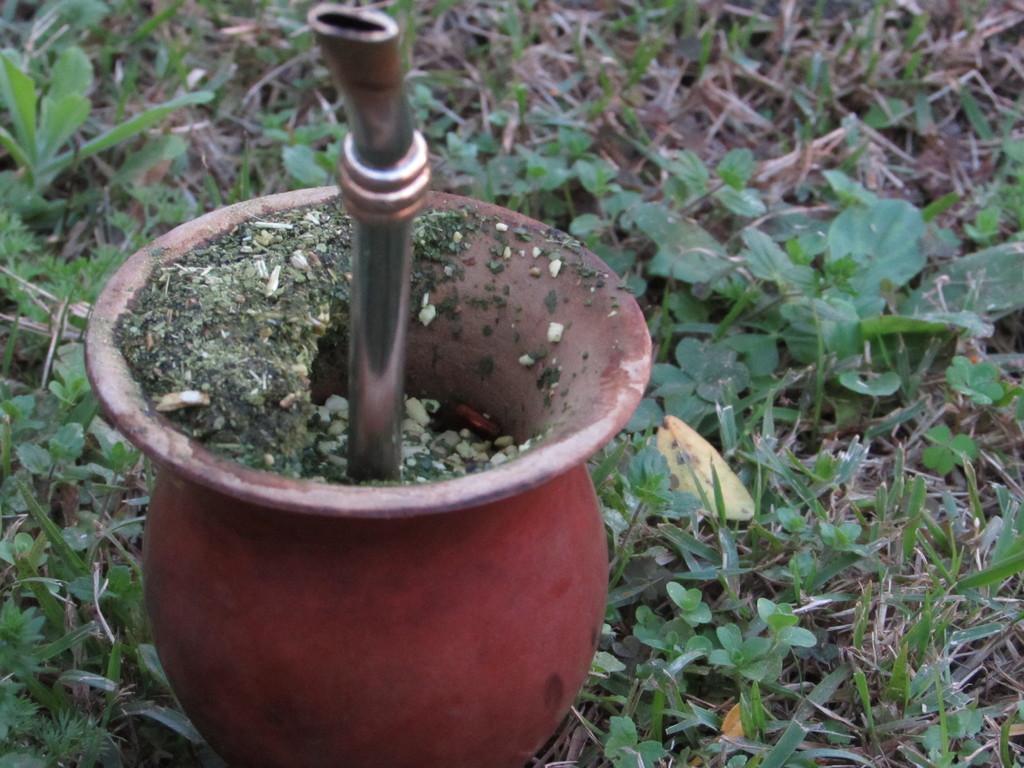Please provide a concise description of this image. In this image there is a metallic object in the flower pot, there are small plants. 